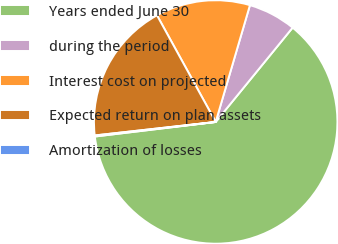Convert chart to OTSL. <chart><loc_0><loc_0><loc_500><loc_500><pie_chart><fcel>Years ended June 30<fcel>during the period<fcel>Interest cost on projected<fcel>Expected return on plan assets<fcel>Amortization of losses<nl><fcel>62.2%<fcel>6.35%<fcel>12.55%<fcel>18.76%<fcel>0.14%<nl></chart> 